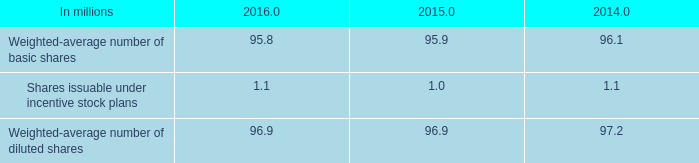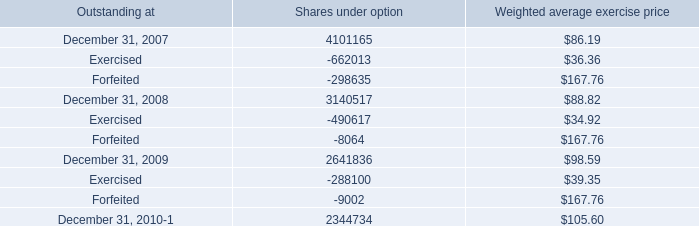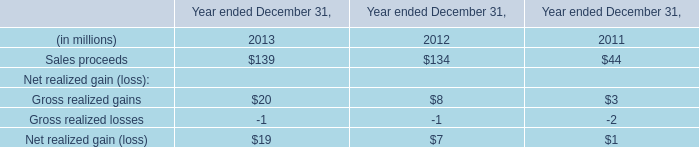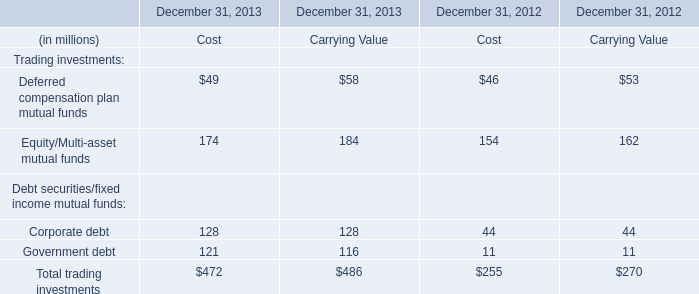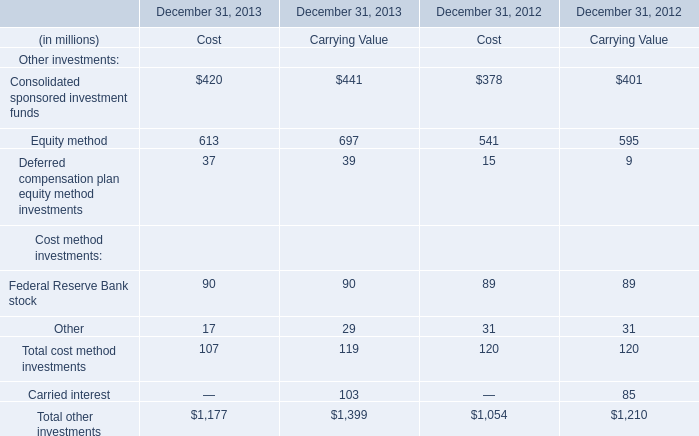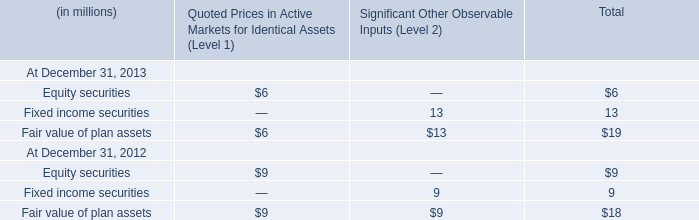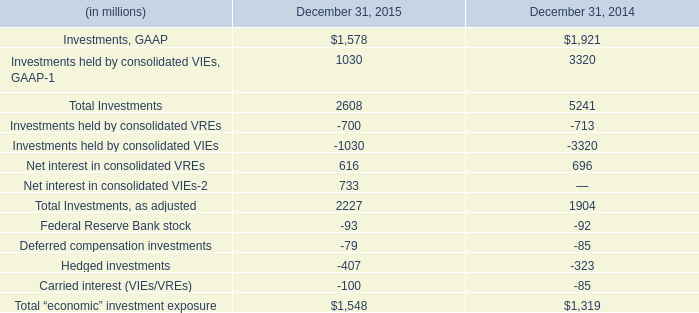In the year with largest amount of Total other investments, what's the sum of Cost? (in million) 
Answer: 1177. 